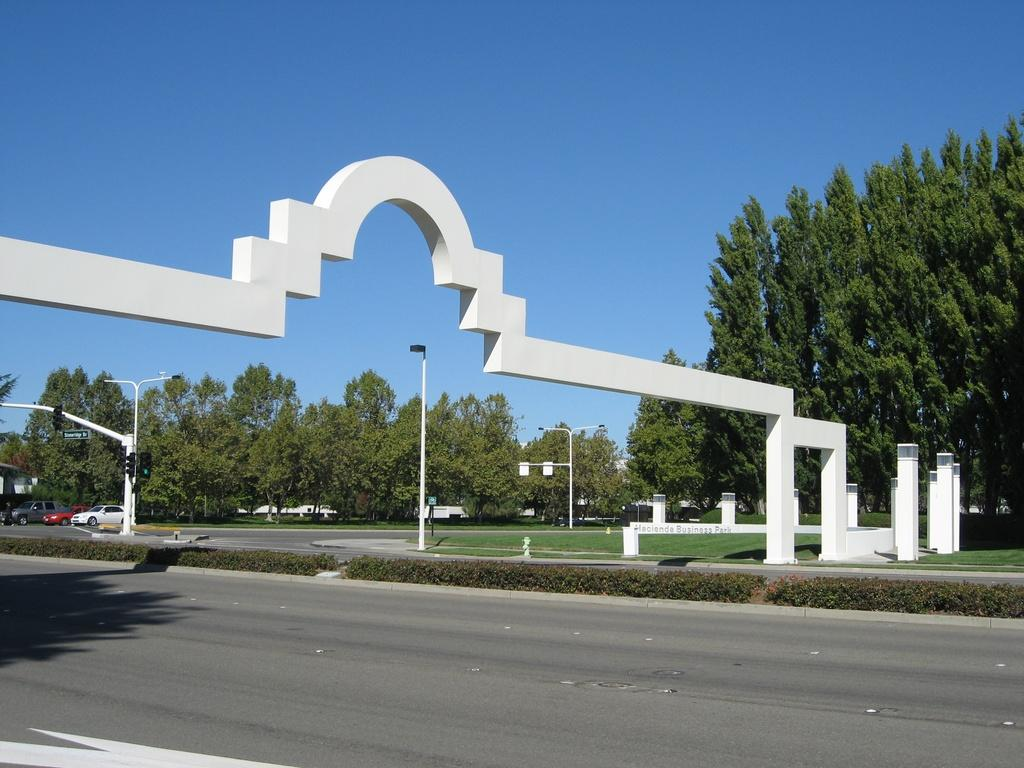What is the main feature of the image? There is a road in the image. What else can be seen along the road? There are poles and traffic signal lights present in the image. Are there any vehicles on the road? Yes, there are cars in the image. What type of vegetation is visible in the image? Trees and grass are present in the image. What is visible in the background of the image? The sky is visible in the background of the image. Reasoning: Let' Let's think step by step in order to produce the conversation. We start by identifying the main subject of the image, which is the road. Then, we describe the other objects and features that are present along the road, such as poles, traffic signal lights, and cars. We also mention the vegetation and the sky visible in the image. Each question is designed to elicit a specific detail about the image that is known from the provided facts. Absurd Question/Answer: What type of mouth can be seen on the traffic signal lights in the image? There are no mouths present on the traffic signal lights in the image. How many screws are visible on the trees in the image? There are no screws visible on the trees in the image. 